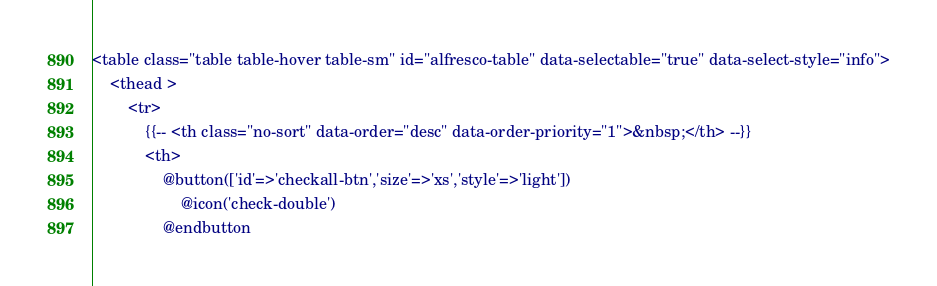<code> <loc_0><loc_0><loc_500><loc_500><_PHP_><table class="table table-hover table-sm" id="alfresco-table" data-selectable="true" data-select-style="info">
	<thead >
		<tr>
			{{-- <th class="no-sort" data-order="desc" data-order-priority="1">&nbsp;</th> --}}
			<th>
				@button(['id'=>'checkall-btn','size'=>'xs','style'=>'light']) 
					@icon('check-double') 
				@endbutton</code> 